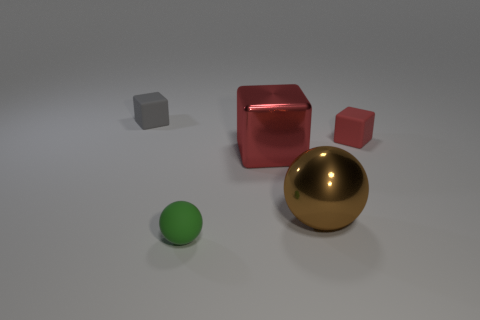There is a large thing that is the same material as the large block; what shape is it?
Offer a very short reply. Sphere. How many tiny rubber blocks are the same color as the large shiny cube?
Your answer should be compact. 1. How many objects are large shiny cubes or metallic things?
Provide a succinct answer. 2. There is a block behind the tiny cube that is to the right of the green rubber sphere; what is it made of?
Provide a succinct answer. Rubber. Is there a small green ball made of the same material as the brown object?
Ensure brevity in your answer.  No. What shape is the green thing to the right of the small matte thing behind the rubber cube that is on the right side of the gray rubber thing?
Provide a short and direct response. Sphere. What material is the small sphere?
Give a very brief answer. Rubber. The big thing that is made of the same material as the big ball is what color?
Offer a very short reply. Red. There is a tiny ball that is on the right side of the gray block; are there any metallic blocks that are to the left of it?
Your answer should be very brief. No. How many other objects are the same shape as the brown metal object?
Provide a short and direct response. 1. 